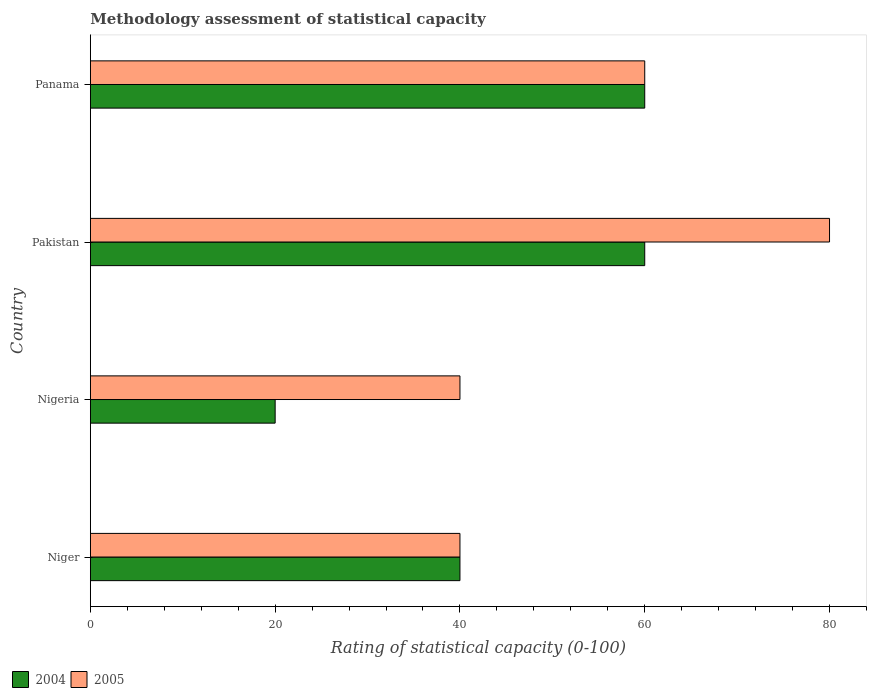How many groups of bars are there?
Provide a short and direct response. 4. Are the number of bars per tick equal to the number of legend labels?
Your answer should be very brief. Yes. Are the number of bars on each tick of the Y-axis equal?
Provide a succinct answer. Yes. What is the label of the 4th group of bars from the top?
Your response must be concise. Niger. In how many cases, is the number of bars for a given country not equal to the number of legend labels?
Keep it short and to the point. 0. What is the rating of statistical capacity in 2004 in Niger?
Ensure brevity in your answer.  40. Across all countries, what is the maximum rating of statistical capacity in 2005?
Make the answer very short. 80. Across all countries, what is the minimum rating of statistical capacity in 2005?
Keep it short and to the point. 40. In which country was the rating of statistical capacity in 2004 maximum?
Your answer should be compact. Pakistan. In which country was the rating of statistical capacity in 2005 minimum?
Give a very brief answer. Niger. What is the total rating of statistical capacity in 2004 in the graph?
Give a very brief answer. 180. What is the average rating of statistical capacity in 2005 per country?
Provide a short and direct response. 55. What is the difference between the rating of statistical capacity in 2004 and rating of statistical capacity in 2005 in Niger?
Offer a terse response. 0. In how many countries, is the rating of statistical capacity in 2005 greater than 48 ?
Provide a short and direct response. 2. What is the ratio of the rating of statistical capacity in 2005 in Niger to that in Panama?
Provide a short and direct response. 0.67. What is the difference between the highest and the second highest rating of statistical capacity in 2004?
Keep it short and to the point. 0. What is the difference between the highest and the lowest rating of statistical capacity in 2005?
Your answer should be compact. 40. In how many countries, is the rating of statistical capacity in 2005 greater than the average rating of statistical capacity in 2005 taken over all countries?
Your response must be concise. 2. Is the sum of the rating of statistical capacity in 2005 in Niger and Panama greater than the maximum rating of statistical capacity in 2004 across all countries?
Provide a succinct answer. Yes. What does the 2nd bar from the top in Niger represents?
Give a very brief answer. 2004. Are all the bars in the graph horizontal?
Make the answer very short. Yes. Does the graph contain any zero values?
Your answer should be very brief. No. How many legend labels are there?
Give a very brief answer. 2. How are the legend labels stacked?
Your answer should be very brief. Horizontal. What is the title of the graph?
Provide a succinct answer. Methodology assessment of statistical capacity. What is the label or title of the X-axis?
Your answer should be very brief. Rating of statistical capacity (0-100). What is the Rating of statistical capacity (0-100) in 2004 in Nigeria?
Offer a terse response. 20. What is the Rating of statistical capacity (0-100) in 2005 in Panama?
Your response must be concise. 60. Across all countries, what is the maximum Rating of statistical capacity (0-100) in 2004?
Give a very brief answer. 60. Across all countries, what is the minimum Rating of statistical capacity (0-100) of 2005?
Your answer should be compact. 40. What is the total Rating of statistical capacity (0-100) of 2004 in the graph?
Provide a short and direct response. 180. What is the total Rating of statistical capacity (0-100) of 2005 in the graph?
Your answer should be very brief. 220. What is the difference between the Rating of statistical capacity (0-100) of 2004 in Niger and that in Nigeria?
Keep it short and to the point. 20. What is the difference between the Rating of statistical capacity (0-100) of 2004 in Nigeria and that in Panama?
Provide a short and direct response. -40. What is the difference between the Rating of statistical capacity (0-100) in 2005 in Nigeria and that in Panama?
Offer a very short reply. -20. What is the difference between the Rating of statistical capacity (0-100) in 2004 in Niger and the Rating of statistical capacity (0-100) in 2005 in Nigeria?
Make the answer very short. 0. What is the difference between the Rating of statistical capacity (0-100) in 2004 in Niger and the Rating of statistical capacity (0-100) in 2005 in Panama?
Provide a short and direct response. -20. What is the difference between the Rating of statistical capacity (0-100) in 2004 in Nigeria and the Rating of statistical capacity (0-100) in 2005 in Pakistan?
Your response must be concise. -60. What is the difference between the Rating of statistical capacity (0-100) of 2004 in Pakistan and the Rating of statistical capacity (0-100) of 2005 in Panama?
Make the answer very short. 0. What is the average Rating of statistical capacity (0-100) in 2004 per country?
Offer a terse response. 45. What is the difference between the Rating of statistical capacity (0-100) of 2004 and Rating of statistical capacity (0-100) of 2005 in Niger?
Make the answer very short. 0. What is the difference between the Rating of statistical capacity (0-100) in 2004 and Rating of statistical capacity (0-100) in 2005 in Nigeria?
Make the answer very short. -20. What is the ratio of the Rating of statistical capacity (0-100) of 2004 in Niger to that in Nigeria?
Your answer should be compact. 2. What is the ratio of the Rating of statistical capacity (0-100) in 2005 in Niger to that in Nigeria?
Offer a very short reply. 1. What is the ratio of the Rating of statistical capacity (0-100) of 2005 in Niger to that in Pakistan?
Ensure brevity in your answer.  0.5. What is the ratio of the Rating of statistical capacity (0-100) of 2004 in Niger to that in Panama?
Give a very brief answer. 0.67. What is the ratio of the Rating of statistical capacity (0-100) in 2005 in Nigeria to that in Pakistan?
Provide a short and direct response. 0.5. What is the ratio of the Rating of statistical capacity (0-100) of 2005 in Nigeria to that in Panama?
Ensure brevity in your answer.  0.67. What is the ratio of the Rating of statistical capacity (0-100) of 2005 in Pakistan to that in Panama?
Offer a very short reply. 1.33. What is the difference between the highest and the second highest Rating of statistical capacity (0-100) of 2005?
Your answer should be compact. 20. What is the difference between the highest and the lowest Rating of statistical capacity (0-100) in 2004?
Give a very brief answer. 40. 